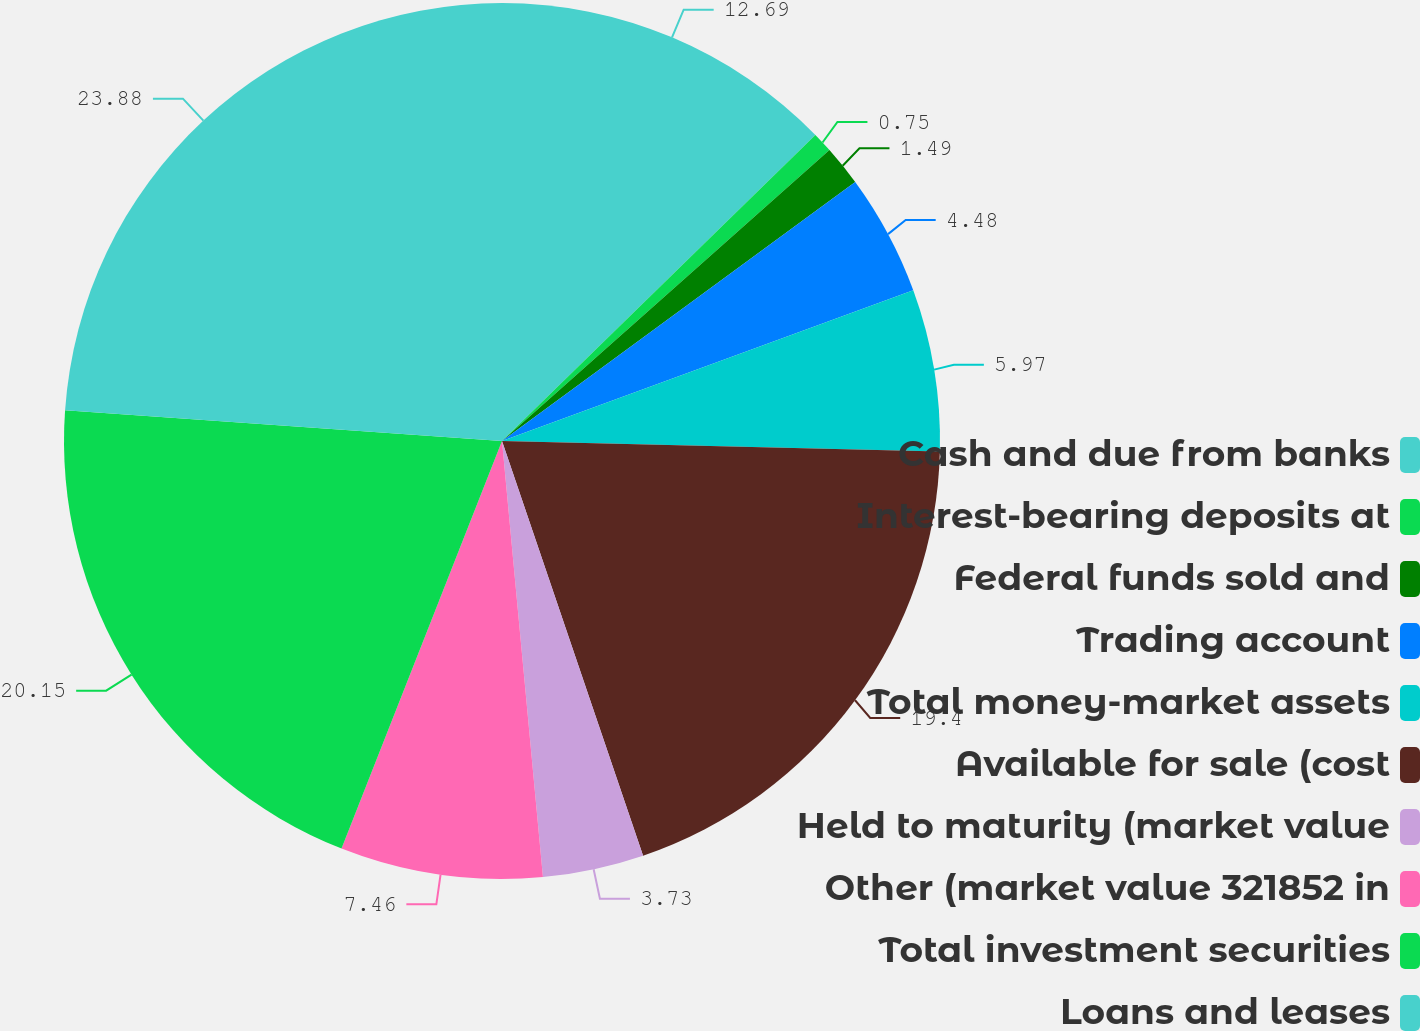<chart> <loc_0><loc_0><loc_500><loc_500><pie_chart><fcel>Cash and due from banks<fcel>Interest-bearing deposits at<fcel>Federal funds sold and<fcel>Trading account<fcel>Total money-market assets<fcel>Available for sale (cost<fcel>Held to maturity (market value<fcel>Other (market value 321852 in<fcel>Total investment securities<fcel>Loans and leases<nl><fcel>12.69%<fcel>0.75%<fcel>1.49%<fcel>4.48%<fcel>5.97%<fcel>19.4%<fcel>3.73%<fcel>7.46%<fcel>20.15%<fcel>23.88%<nl></chart> 